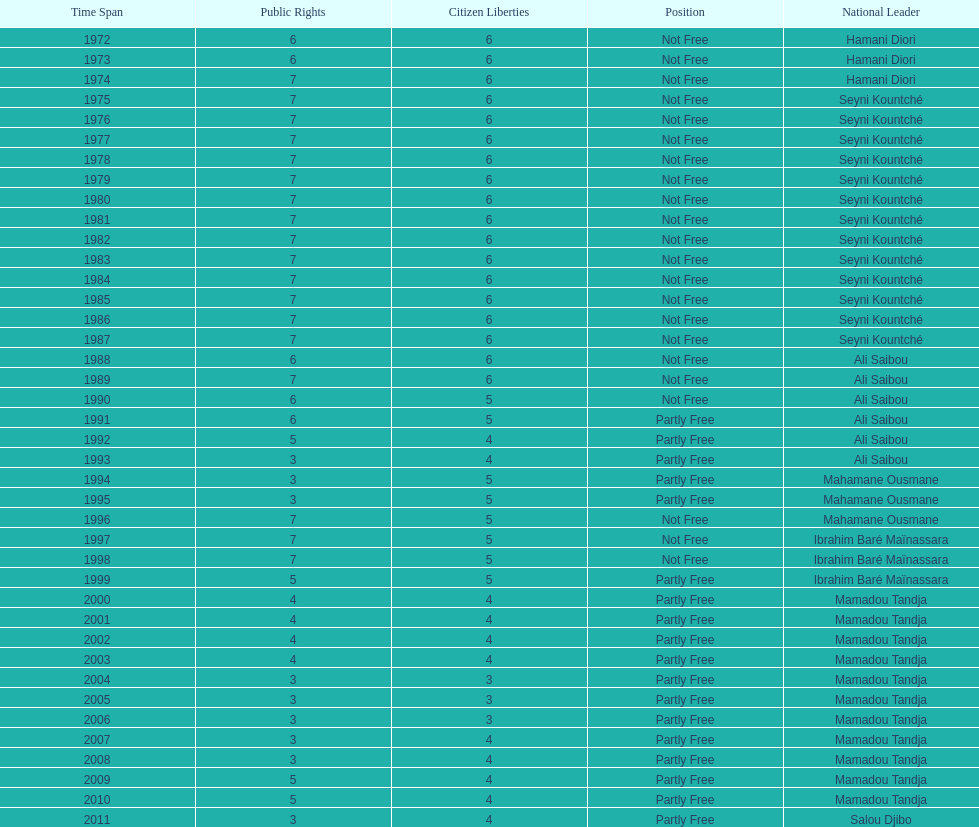How many years was ali saibou president? 6. 